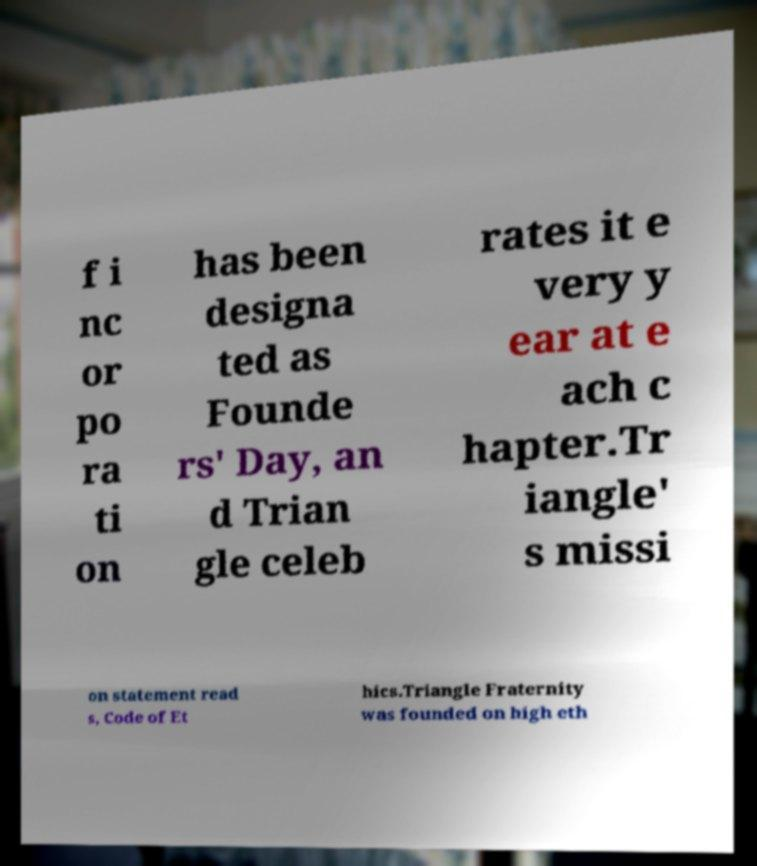Can you read and provide the text displayed in the image?This photo seems to have some interesting text. Can you extract and type it out for me? f i nc or po ra ti on has been designa ted as Founde rs' Day, an d Trian gle celeb rates it e very y ear at e ach c hapter.Tr iangle' s missi on statement read s, Code of Et hics.Triangle Fraternity was founded on high eth 